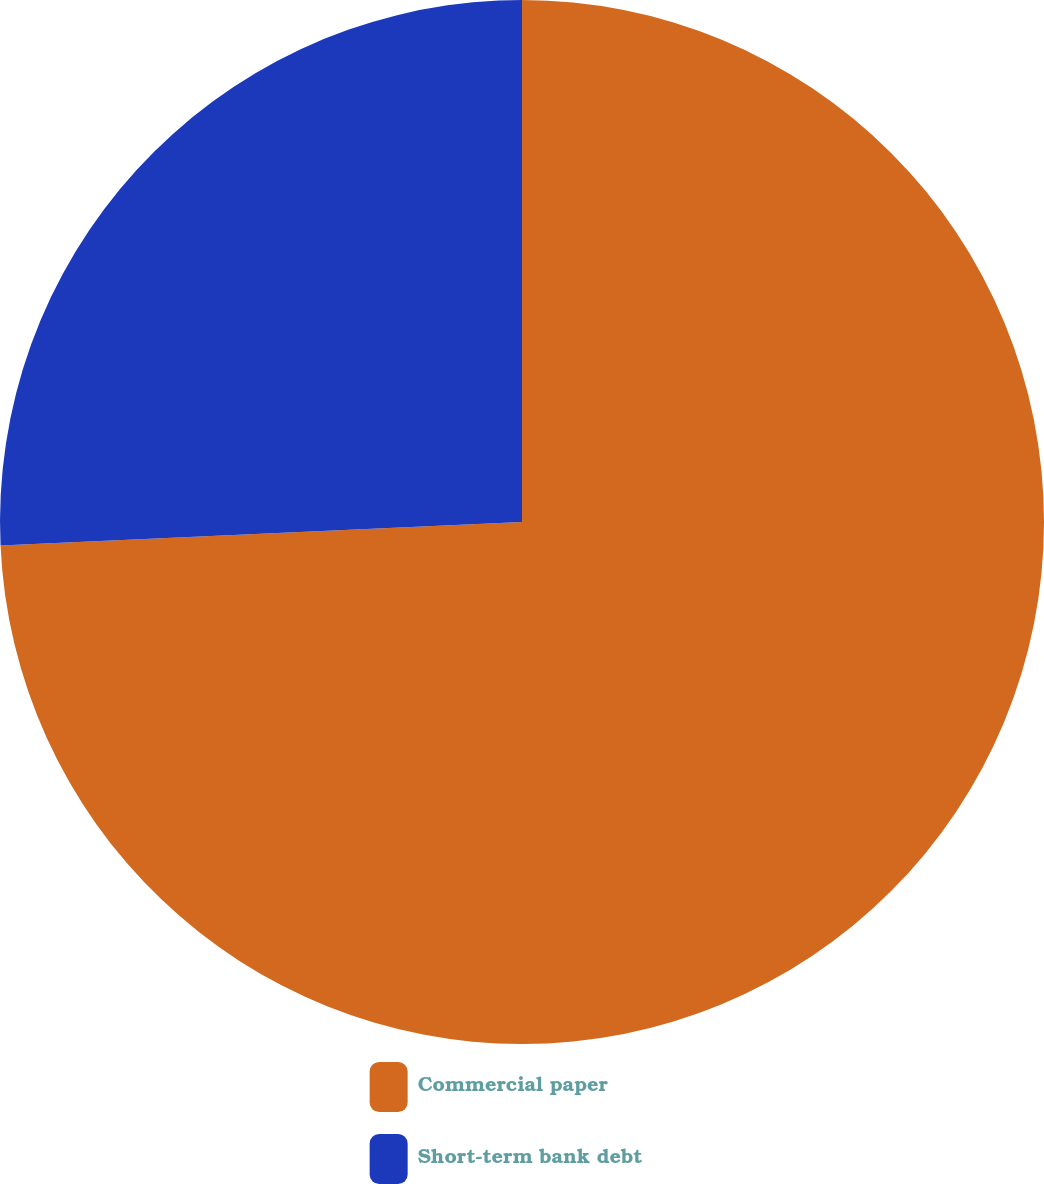Convert chart to OTSL. <chart><loc_0><loc_0><loc_500><loc_500><pie_chart><fcel>Commercial paper<fcel>Short-term bank debt<nl><fcel>74.28%<fcel>25.72%<nl></chart> 